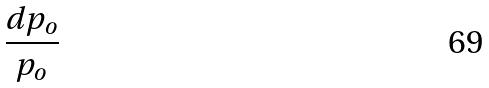Convert formula to latex. <formula><loc_0><loc_0><loc_500><loc_500>\frac { d p _ { o } } { p _ { o } }</formula> 